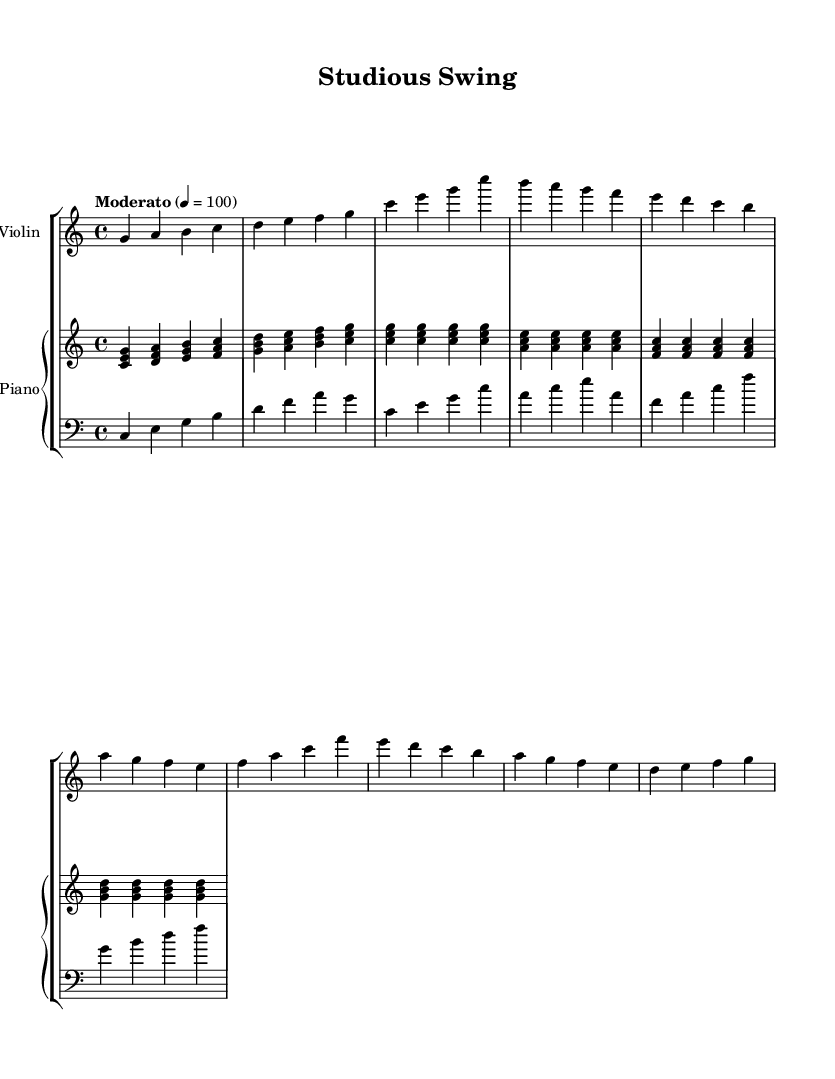What is the key signature of this music? The key signature is C major, which indicates there are no sharps or flats.
Answer: C major What is the time signature of this music? The time signature is 4/4, meaning there are four beats in each measure, and the quarter note gets one beat.
Answer: 4/4 What is the tempo marking of this piece? The tempo marking indicates "Moderato" with a metronome mark of 100, suggesting a moderate speed for the piece.
Answer: Moderato How many measures are in the A section? The A section contains 8 measures, which can be seen by counting the measures of music provided for that section.
Answer: 8 What type of jazz harmony is suggested in the piano part? The piano part primarily uses triads, with multiple chords played simultaneously, creating a jazzy harmonic texture typical in jazz fusion compositions.
Answer: Triads What rhythmic pattern is introduced in the B section? The B section begins to incorporate syncopation, which is a common characteristic in jazz, where off-beat rhythms create a sense of swing.
Answer: Syncopation What instrument primarily carries the melody in this piece? The violin is indicated to primarily carry the melody, as it has the highest part, often playing more prominent melodic lines than the accompanying instruments.
Answer: Violin 